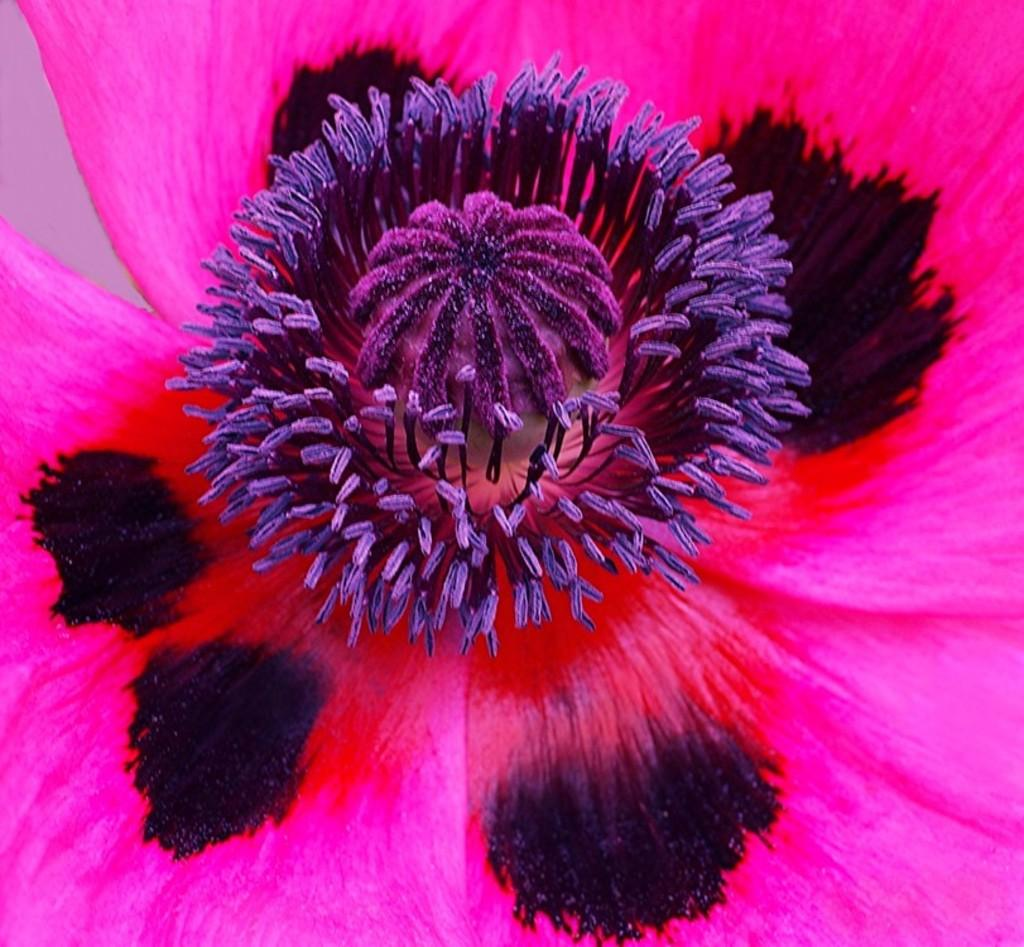What is the main subject of the image? The main subject of the image is a flower. Can you describe the colors of the flower? The flower has pink, black, and purple colors. What memories are associated with the cemetery in the image? There is no cemetery present in the image; it features a flower with pink, black, and purple colors. 